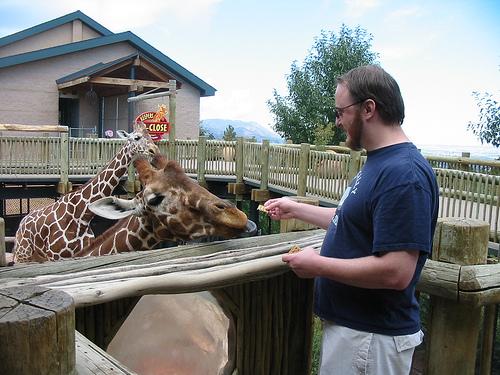Does the man have a beard?
Quick response, please. Yes. They are waving at a giraffe?
Concise answer only. No. What color is the giraffe's tongue?
Write a very short answer. Black. Are those baby giraffes?
Short answer required. Yes. 